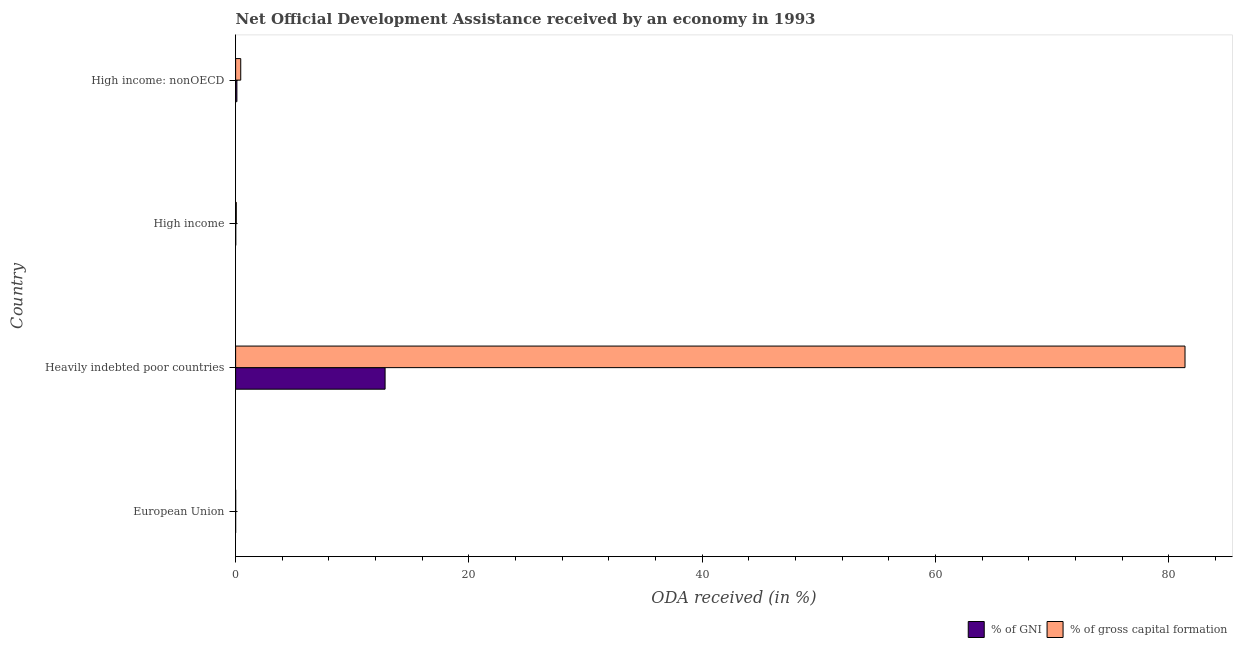How many different coloured bars are there?
Provide a succinct answer. 2. Are the number of bars on each tick of the Y-axis equal?
Give a very brief answer. Yes. How many bars are there on the 3rd tick from the top?
Provide a short and direct response. 2. In how many cases, is the number of bars for a given country not equal to the number of legend labels?
Your answer should be very brief. 0. What is the oda received as percentage of gni in European Union?
Provide a succinct answer. 0. Across all countries, what is the maximum oda received as percentage of gni?
Your answer should be very brief. 12.81. Across all countries, what is the minimum oda received as percentage of gni?
Your response must be concise. 0. In which country was the oda received as percentage of gni maximum?
Your response must be concise. Heavily indebted poor countries. In which country was the oda received as percentage of gni minimum?
Provide a short and direct response. European Union. What is the total oda received as percentage of gross capital formation in the graph?
Offer a very short reply. 81.88. What is the difference between the oda received as percentage of gni in Heavily indebted poor countries and that in High income?
Make the answer very short. 12.8. What is the difference between the oda received as percentage of gni in Heavily indebted poor countries and the oda received as percentage of gross capital formation in High income: nonOECD?
Offer a very short reply. 12.37. What is the average oda received as percentage of gross capital formation per country?
Provide a short and direct response. 20.47. What is the difference between the oda received as percentage of gni and oda received as percentage of gross capital formation in Heavily indebted poor countries?
Your answer should be compact. -68.57. What is the ratio of the oda received as percentage of gni in European Union to that in High income: nonOECD?
Keep it short and to the point. 0.01. Is the oda received as percentage of gross capital formation in High income less than that in High income: nonOECD?
Ensure brevity in your answer.  Yes. What is the difference between the highest and the second highest oda received as percentage of gross capital formation?
Your response must be concise. 80.94. What is the difference between the highest and the lowest oda received as percentage of gross capital formation?
Provide a succinct answer. 81.38. Is the sum of the oda received as percentage of gross capital formation in European Union and High income greater than the maximum oda received as percentage of gni across all countries?
Your response must be concise. No. What does the 1st bar from the top in European Union represents?
Offer a terse response. % of gross capital formation. What does the 2nd bar from the bottom in High income represents?
Your response must be concise. % of gross capital formation. How many bars are there?
Ensure brevity in your answer.  8. Are all the bars in the graph horizontal?
Give a very brief answer. Yes. Are the values on the major ticks of X-axis written in scientific E-notation?
Your answer should be compact. No. Does the graph contain any zero values?
Keep it short and to the point. No. Does the graph contain grids?
Your answer should be very brief. No. How many legend labels are there?
Your answer should be compact. 2. What is the title of the graph?
Your answer should be very brief. Net Official Development Assistance received by an economy in 1993. Does "Primary income" appear as one of the legend labels in the graph?
Offer a very short reply. No. What is the label or title of the X-axis?
Your answer should be very brief. ODA received (in %). What is the ODA received (in %) in % of GNI in European Union?
Give a very brief answer. 0. What is the ODA received (in %) in % of gross capital formation in European Union?
Your response must be concise. 0. What is the ODA received (in %) of % of GNI in Heavily indebted poor countries?
Give a very brief answer. 12.81. What is the ODA received (in %) of % of gross capital formation in Heavily indebted poor countries?
Provide a succinct answer. 81.38. What is the ODA received (in %) in % of GNI in High income?
Offer a very short reply. 0.01. What is the ODA received (in %) in % of gross capital formation in High income?
Your answer should be very brief. 0.06. What is the ODA received (in %) of % of GNI in High income: nonOECD?
Keep it short and to the point. 0.11. What is the ODA received (in %) in % of gross capital formation in High income: nonOECD?
Your response must be concise. 0.44. Across all countries, what is the maximum ODA received (in %) of % of GNI?
Provide a short and direct response. 12.81. Across all countries, what is the maximum ODA received (in %) in % of gross capital formation?
Your response must be concise. 81.38. Across all countries, what is the minimum ODA received (in %) of % of GNI?
Ensure brevity in your answer.  0. Across all countries, what is the minimum ODA received (in %) of % of gross capital formation?
Offer a terse response. 0. What is the total ODA received (in %) of % of GNI in the graph?
Give a very brief answer. 12.94. What is the total ODA received (in %) of % of gross capital formation in the graph?
Your response must be concise. 81.88. What is the difference between the ODA received (in %) in % of GNI in European Union and that in Heavily indebted poor countries?
Provide a succinct answer. -12.81. What is the difference between the ODA received (in %) in % of gross capital formation in European Union and that in Heavily indebted poor countries?
Ensure brevity in your answer.  -81.38. What is the difference between the ODA received (in %) in % of GNI in European Union and that in High income?
Your answer should be compact. -0.01. What is the difference between the ODA received (in %) of % of gross capital formation in European Union and that in High income?
Offer a terse response. -0.05. What is the difference between the ODA received (in %) of % of GNI in European Union and that in High income: nonOECD?
Your answer should be very brief. -0.11. What is the difference between the ODA received (in %) of % of gross capital formation in European Union and that in High income: nonOECD?
Make the answer very short. -0.43. What is the difference between the ODA received (in %) of % of GNI in Heavily indebted poor countries and that in High income?
Make the answer very short. 12.8. What is the difference between the ODA received (in %) of % of gross capital formation in Heavily indebted poor countries and that in High income?
Offer a very short reply. 81.32. What is the difference between the ODA received (in %) in % of GNI in Heavily indebted poor countries and that in High income: nonOECD?
Make the answer very short. 12.7. What is the difference between the ODA received (in %) of % of gross capital formation in Heavily indebted poor countries and that in High income: nonOECD?
Ensure brevity in your answer.  80.94. What is the difference between the ODA received (in %) in % of GNI in High income and that in High income: nonOECD?
Provide a short and direct response. -0.1. What is the difference between the ODA received (in %) in % of gross capital formation in High income and that in High income: nonOECD?
Keep it short and to the point. -0.38. What is the difference between the ODA received (in %) of % of GNI in European Union and the ODA received (in %) of % of gross capital formation in Heavily indebted poor countries?
Provide a short and direct response. -81.38. What is the difference between the ODA received (in %) of % of GNI in European Union and the ODA received (in %) of % of gross capital formation in High income?
Make the answer very short. -0.06. What is the difference between the ODA received (in %) in % of GNI in European Union and the ODA received (in %) in % of gross capital formation in High income: nonOECD?
Offer a terse response. -0.44. What is the difference between the ODA received (in %) in % of GNI in Heavily indebted poor countries and the ODA received (in %) in % of gross capital formation in High income?
Offer a very short reply. 12.76. What is the difference between the ODA received (in %) of % of GNI in Heavily indebted poor countries and the ODA received (in %) of % of gross capital formation in High income: nonOECD?
Your answer should be compact. 12.37. What is the difference between the ODA received (in %) of % of GNI in High income and the ODA received (in %) of % of gross capital formation in High income: nonOECD?
Keep it short and to the point. -0.42. What is the average ODA received (in %) of % of GNI per country?
Your response must be concise. 3.23. What is the average ODA received (in %) of % of gross capital formation per country?
Offer a very short reply. 20.47. What is the difference between the ODA received (in %) of % of GNI and ODA received (in %) of % of gross capital formation in European Union?
Your response must be concise. -0. What is the difference between the ODA received (in %) of % of GNI and ODA received (in %) of % of gross capital formation in Heavily indebted poor countries?
Your response must be concise. -68.57. What is the difference between the ODA received (in %) in % of GNI and ODA received (in %) in % of gross capital formation in High income?
Provide a short and direct response. -0.04. What is the difference between the ODA received (in %) of % of GNI and ODA received (in %) of % of gross capital formation in High income: nonOECD?
Provide a succinct answer. -0.33. What is the ratio of the ODA received (in %) in % of GNI in European Union to that in Heavily indebted poor countries?
Offer a terse response. 0. What is the ratio of the ODA received (in %) in % of GNI in European Union to that in High income?
Offer a terse response. 0.07. What is the ratio of the ODA received (in %) in % of gross capital formation in European Union to that in High income?
Keep it short and to the point. 0.08. What is the ratio of the ODA received (in %) of % of GNI in European Union to that in High income: nonOECD?
Provide a short and direct response. 0.01. What is the ratio of the ODA received (in %) of % of gross capital formation in European Union to that in High income: nonOECD?
Keep it short and to the point. 0.01. What is the ratio of the ODA received (in %) of % of GNI in Heavily indebted poor countries to that in High income?
Make the answer very short. 971.83. What is the ratio of the ODA received (in %) in % of gross capital formation in Heavily indebted poor countries to that in High income?
Your answer should be very brief. 1418.43. What is the ratio of the ODA received (in %) in % of GNI in Heavily indebted poor countries to that in High income: nonOECD?
Offer a very short reply. 117.55. What is the ratio of the ODA received (in %) of % of gross capital formation in Heavily indebted poor countries to that in High income: nonOECD?
Your answer should be compact. 185.72. What is the ratio of the ODA received (in %) of % of GNI in High income to that in High income: nonOECD?
Provide a short and direct response. 0.12. What is the ratio of the ODA received (in %) in % of gross capital formation in High income to that in High income: nonOECD?
Offer a terse response. 0.13. What is the difference between the highest and the second highest ODA received (in %) of % of GNI?
Give a very brief answer. 12.7. What is the difference between the highest and the second highest ODA received (in %) of % of gross capital formation?
Provide a succinct answer. 80.94. What is the difference between the highest and the lowest ODA received (in %) in % of GNI?
Offer a terse response. 12.81. What is the difference between the highest and the lowest ODA received (in %) of % of gross capital formation?
Make the answer very short. 81.38. 